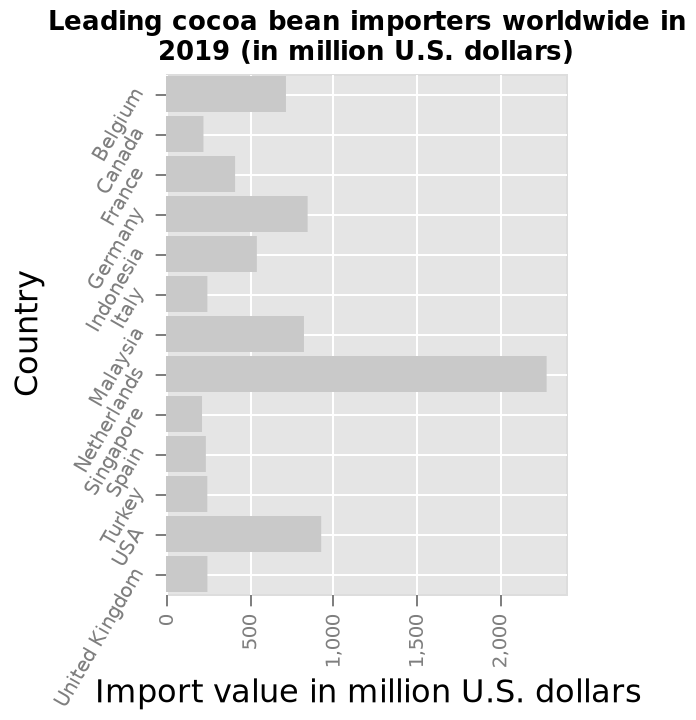<image>
Which country has the highest import value of cocoa beans?  The Netherlands has the highest import value of cocoa beans. What are the top five countries with the highest import values of cocoa beans? The top five countries with the highest import values of cocoa beans are the Netherlands, USA, Malaysia, Germany, and Belgium. 